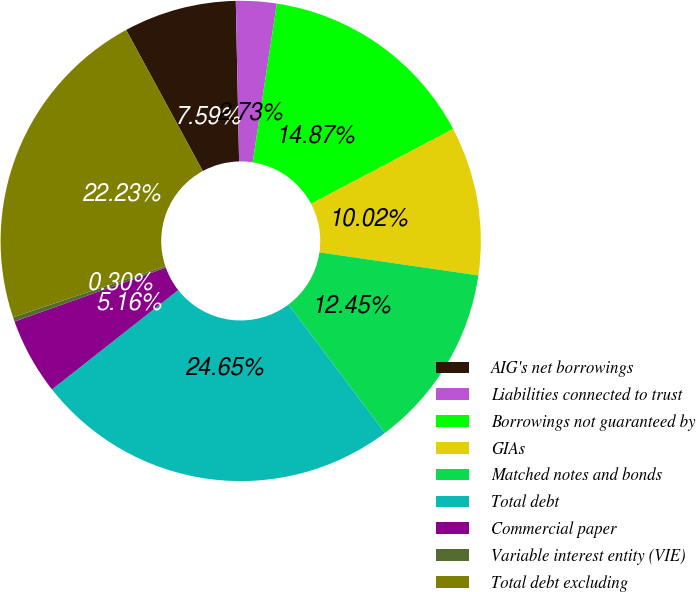Convert chart to OTSL. <chart><loc_0><loc_0><loc_500><loc_500><pie_chart><fcel>AIG's net borrowings<fcel>Liabilities connected to trust<fcel>Borrowings not guaranteed by<fcel>GIAs<fcel>Matched notes and bonds<fcel>Total debt<fcel>Commercial paper<fcel>Variable interest entity (VIE)<fcel>Total debt excluding<nl><fcel>7.59%<fcel>2.73%<fcel>14.87%<fcel>10.02%<fcel>12.45%<fcel>24.65%<fcel>5.16%<fcel>0.3%<fcel>22.23%<nl></chart> 